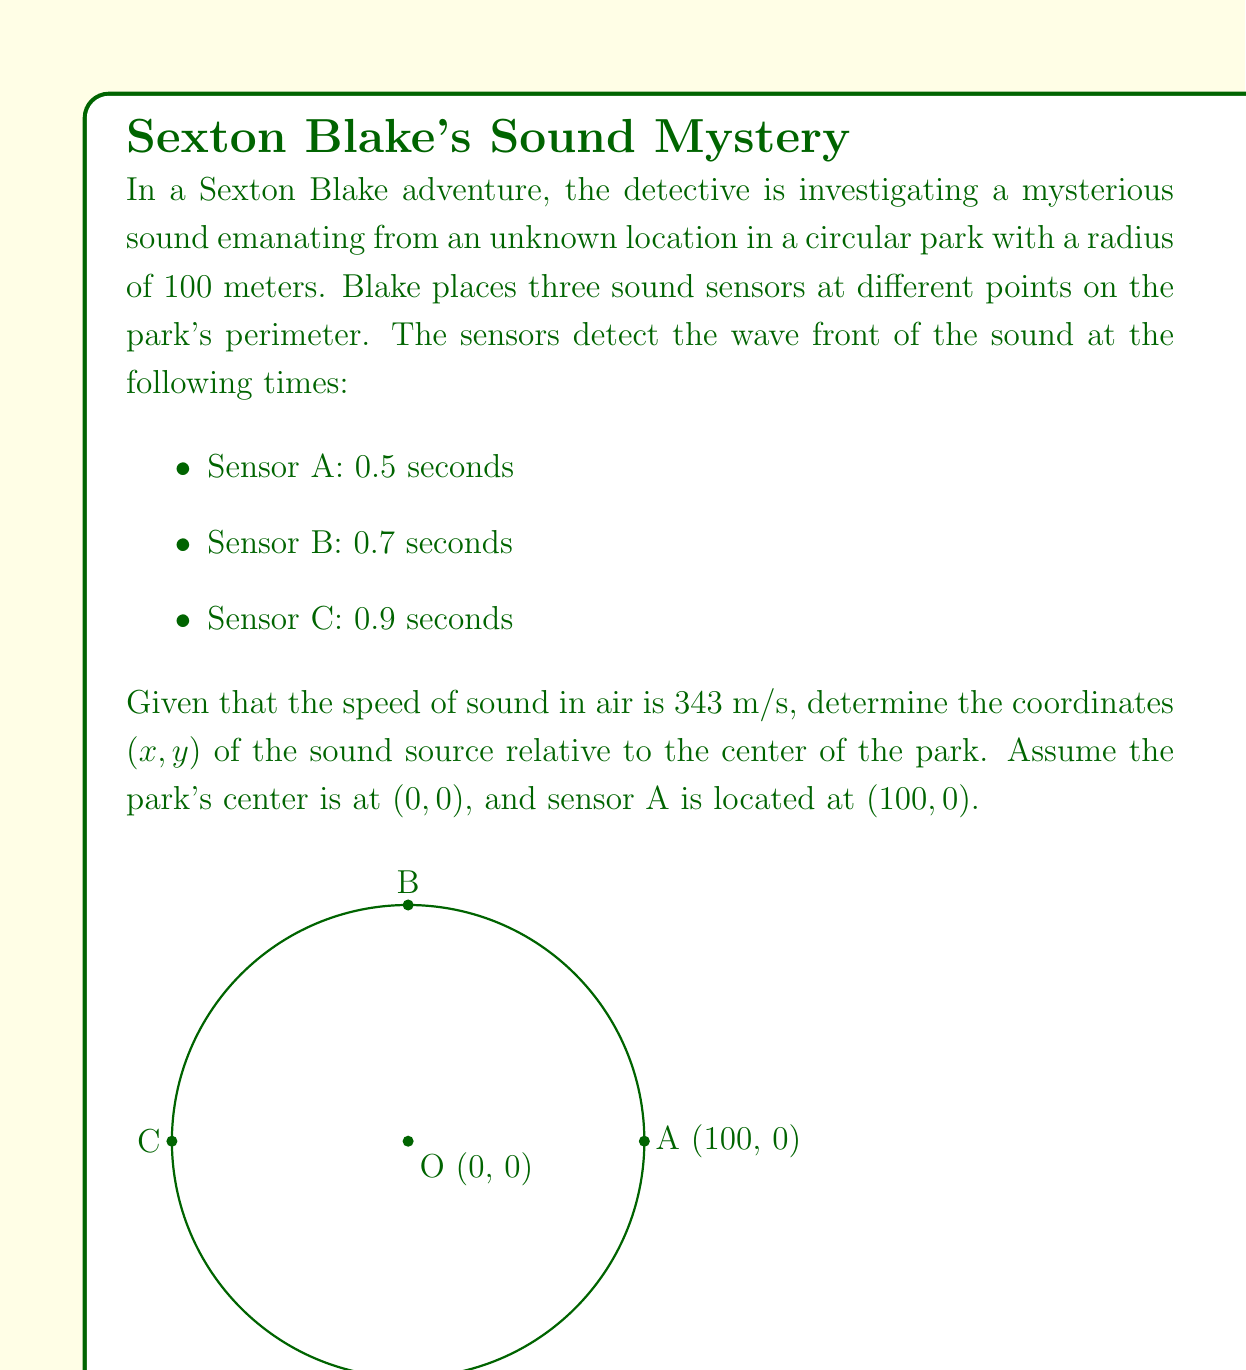Help me with this question. To solve this problem, we'll use the wave equation and the concept of triangulation. Let's approach this step-by-step:

1) First, calculate the distances from each sensor to the sound source:
   Distance = Speed × Time
   For Sensor A: $d_A = 343 \times 0.5 = 171.5$ m
   For Sensor B: $d_B = 343 \times 0.7 = 240.1$ m
   For Sensor C: $d_C = 343 \times 0.9 = 308.7$ m

2) Let the coordinates of the sound source be (x, y). We can set up three equations based on the distances:

   $$(x-100)^2 + y^2 = 171.5^2$$
   $$x^2 + (y-100)^2 = 240.1^2$$
   $$(x+100)^2 + y^2 = 308.7^2$$

3) Subtracting the first equation from the third:

   $$(x+100)^2 - (x-100)^2 = 308.7^2 - 171.5^2$$
   $$4x \times 100 = 308.7^2 - 171.5^2$$
   $$x = \frac{308.7^2 - 171.5^2}{400} = 51.85$$

4) Substitute this x-value into the first equation:

   $$(51.85-100)^2 + y^2 = 171.5^2$$
   $$y^2 = 171.5^2 - (-48.15)^2 = 29412.25 - 2318.4225 = 27093.8275$$
   $$y = \sqrt{27093.8275} = 164.6$$

5) Verify with the second equation:

   $$51.85^2 + (164.6-100)^2 \approx 240.1^2$$

The coordinates satisfy all three equations, confirming our solution.
Answer: (51.85, 164.6) 